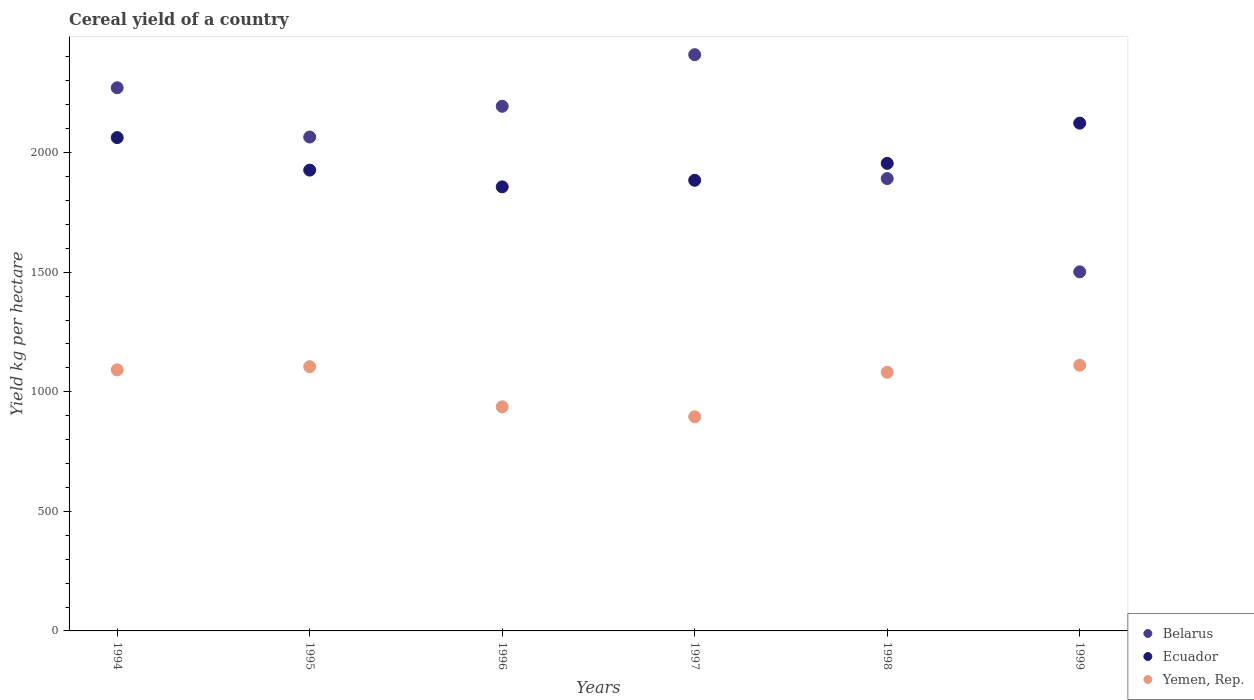What is the total cereal yield in Yemen, Rep. in 1995?
Offer a very short reply. 1104.99. Across all years, what is the maximum total cereal yield in Belarus?
Make the answer very short. 2409.44. Across all years, what is the minimum total cereal yield in Yemen, Rep.?
Offer a terse response. 895.44. In which year was the total cereal yield in Belarus maximum?
Your response must be concise. 1997. In which year was the total cereal yield in Belarus minimum?
Provide a short and direct response. 1999. What is the total total cereal yield in Yemen, Rep. in the graph?
Provide a succinct answer. 6221.8. What is the difference between the total cereal yield in Belarus in 1995 and that in 1998?
Make the answer very short. 173.69. What is the difference between the total cereal yield in Yemen, Rep. in 1994 and the total cereal yield in Ecuador in 1995?
Make the answer very short. -835.14. What is the average total cereal yield in Yemen, Rep. per year?
Provide a succinct answer. 1036.97. In the year 1997, what is the difference between the total cereal yield in Ecuador and total cereal yield in Belarus?
Offer a very short reply. -525.23. What is the ratio of the total cereal yield in Ecuador in 1995 to that in 1996?
Your response must be concise. 1.04. Is the difference between the total cereal yield in Ecuador in 1998 and 1999 greater than the difference between the total cereal yield in Belarus in 1998 and 1999?
Provide a short and direct response. No. What is the difference between the highest and the second highest total cereal yield in Belarus?
Your answer should be compact. 138.28. What is the difference between the highest and the lowest total cereal yield in Belarus?
Ensure brevity in your answer.  907.98. Is the sum of the total cereal yield in Belarus in 1994 and 1998 greater than the maximum total cereal yield in Yemen, Rep. across all years?
Offer a terse response. Yes. Is it the case that in every year, the sum of the total cereal yield in Ecuador and total cereal yield in Yemen, Rep.  is greater than the total cereal yield in Belarus?
Make the answer very short. Yes. Is the total cereal yield in Belarus strictly less than the total cereal yield in Ecuador over the years?
Your answer should be very brief. No. Are the values on the major ticks of Y-axis written in scientific E-notation?
Provide a short and direct response. No. Does the graph contain grids?
Give a very brief answer. No. Where does the legend appear in the graph?
Make the answer very short. Bottom right. How many legend labels are there?
Your answer should be very brief. 3. What is the title of the graph?
Your response must be concise. Cereal yield of a country. What is the label or title of the X-axis?
Your answer should be very brief. Years. What is the label or title of the Y-axis?
Your answer should be compact. Yield kg per hectare. What is the Yield kg per hectare of Belarus in 1994?
Your response must be concise. 2271.15. What is the Yield kg per hectare of Ecuador in 1994?
Your answer should be very brief. 2062.74. What is the Yield kg per hectare in Yemen, Rep. in 1994?
Your response must be concise. 1091.65. What is the Yield kg per hectare in Belarus in 1995?
Provide a short and direct response. 2065.16. What is the Yield kg per hectare of Ecuador in 1995?
Keep it short and to the point. 1926.79. What is the Yield kg per hectare of Yemen, Rep. in 1995?
Keep it short and to the point. 1104.99. What is the Yield kg per hectare of Belarus in 1996?
Ensure brevity in your answer.  2193.68. What is the Yield kg per hectare of Ecuador in 1996?
Offer a very short reply. 1856.78. What is the Yield kg per hectare in Yemen, Rep. in 1996?
Keep it short and to the point. 937.09. What is the Yield kg per hectare of Belarus in 1997?
Provide a short and direct response. 2409.44. What is the Yield kg per hectare of Ecuador in 1997?
Give a very brief answer. 1884.2. What is the Yield kg per hectare of Yemen, Rep. in 1997?
Provide a succinct answer. 895.44. What is the Yield kg per hectare in Belarus in 1998?
Make the answer very short. 1891.47. What is the Yield kg per hectare in Ecuador in 1998?
Make the answer very short. 1955.01. What is the Yield kg per hectare in Yemen, Rep. in 1998?
Keep it short and to the point. 1081.46. What is the Yield kg per hectare of Belarus in 1999?
Your response must be concise. 1501.45. What is the Yield kg per hectare of Ecuador in 1999?
Give a very brief answer. 2123.2. What is the Yield kg per hectare in Yemen, Rep. in 1999?
Give a very brief answer. 1111.16. Across all years, what is the maximum Yield kg per hectare of Belarus?
Ensure brevity in your answer.  2409.44. Across all years, what is the maximum Yield kg per hectare in Ecuador?
Your response must be concise. 2123.2. Across all years, what is the maximum Yield kg per hectare in Yemen, Rep.?
Your answer should be very brief. 1111.16. Across all years, what is the minimum Yield kg per hectare in Belarus?
Provide a short and direct response. 1501.45. Across all years, what is the minimum Yield kg per hectare in Ecuador?
Keep it short and to the point. 1856.78. Across all years, what is the minimum Yield kg per hectare of Yemen, Rep.?
Make the answer very short. 895.44. What is the total Yield kg per hectare in Belarus in the graph?
Provide a succinct answer. 1.23e+04. What is the total Yield kg per hectare in Ecuador in the graph?
Provide a short and direct response. 1.18e+04. What is the total Yield kg per hectare in Yemen, Rep. in the graph?
Your response must be concise. 6221.8. What is the difference between the Yield kg per hectare in Belarus in 1994 and that in 1995?
Make the answer very short. 205.99. What is the difference between the Yield kg per hectare in Ecuador in 1994 and that in 1995?
Provide a succinct answer. 135.95. What is the difference between the Yield kg per hectare of Yemen, Rep. in 1994 and that in 1995?
Your answer should be very brief. -13.35. What is the difference between the Yield kg per hectare of Belarus in 1994 and that in 1996?
Ensure brevity in your answer.  77.47. What is the difference between the Yield kg per hectare in Ecuador in 1994 and that in 1996?
Offer a terse response. 205.97. What is the difference between the Yield kg per hectare in Yemen, Rep. in 1994 and that in 1996?
Keep it short and to the point. 154.56. What is the difference between the Yield kg per hectare of Belarus in 1994 and that in 1997?
Keep it short and to the point. -138.28. What is the difference between the Yield kg per hectare of Ecuador in 1994 and that in 1997?
Your response must be concise. 178.54. What is the difference between the Yield kg per hectare in Yemen, Rep. in 1994 and that in 1997?
Give a very brief answer. 196.21. What is the difference between the Yield kg per hectare in Belarus in 1994 and that in 1998?
Your response must be concise. 379.68. What is the difference between the Yield kg per hectare of Ecuador in 1994 and that in 1998?
Offer a very short reply. 107.73. What is the difference between the Yield kg per hectare of Yemen, Rep. in 1994 and that in 1998?
Provide a succinct answer. 10.19. What is the difference between the Yield kg per hectare of Belarus in 1994 and that in 1999?
Offer a terse response. 769.7. What is the difference between the Yield kg per hectare in Ecuador in 1994 and that in 1999?
Your response must be concise. -60.46. What is the difference between the Yield kg per hectare in Yemen, Rep. in 1994 and that in 1999?
Provide a succinct answer. -19.51. What is the difference between the Yield kg per hectare of Belarus in 1995 and that in 1996?
Keep it short and to the point. -128.51. What is the difference between the Yield kg per hectare in Ecuador in 1995 and that in 1996?
Keep it short and to the point. 70.01. What is the difference between the Yield kg per hectare in Yemen, Rep. in 1995 and that in 1996?
Your answer should be very brief. 167.91. What is the difference between the Yield kg per hectare of Belarus in 1995 and that in 1997?
Offer a very short reply. -344.27. What is the difference between the Yield kg per hectare in Ecuador in 1995 and that in 1997?
Your answer should be compact. 42.59. What is the difference between the Yield kg per hectare of Yemen, Rep. in 1995 and that in 1997?
Provide a succinct answer. 209.55. What is the difference between the Yield kg per hectare in Belarus in 1995 and that in 1998?
Your response must be concise. 173.69. What is the difference between the Yield kg per hectare in Ecuador in 1995 and that in 1998?
Your answer should be compact. -28.22. What is the difference between the Yield kg per hectare in Yemen, Rep. in 1995 and that in 1998?
Keep it short and to the point. 23.53. What is the difference between the Yield kg per hectare of Belarus in 1995 and that in 1999?
Your answer should be compact. 563.71. What is the difference between the Yield kg per hectare in Ecuador in 1995 and that in 1999?
Keep it short and to the point. -196.41. What is the difference between the Yield kg per hectare of Yemen, Rep. in 1995 and that in 1999?
Keep it short and to the point. -6.16. What is the difference between the Yield kg per hectare of Belarus in 1996 and that in 1997?
Make the answer very short. -215.76. What is the difference between the Yield kg per hectare of Ecuador in 1996 and that in 1997?
Give a very brief answer. -27.43. What is the difference between the Yield kg per hectare in Yemen, Rep. in 1996 and that in 1997?
Provide a succinct answer. 41.64. What is the difference between the Yield kg per hectare of Belarus in 1996 and that in 1998?
Provide a short and direct response. 302.2. What is the difference between the Yield kg per hectare of Ecuador in 1996 and that in 1998?
Give a very brief answer. -98.24. What is the difference between the Yield kg per hectare of Yemen, Rep. in 1996 and that in 1998?
Keep it short and to the point. -144.37. What is the difference between the Yield kg per hectare of Belarus in 1996 and that in 1999?
Your answer should be very brief. 692.23. What is the difference between the Yield kg per hectare in Ecuador in 1996 and that in 1999?
Your response must be concise. -266.43. What is the difference between the Yield kg per hectare in Yemen, Rep. in 1996 and that in 1999?
Your answer should be very brief. -174.07. What is the difference between the Yield kg per hectare in Belarus in 1997 and that in 1998?
Provide a short and direct response. 517.96. What is the difference between the Yield kg per hectare of Ecuador in 1997 and that in 1998?
Provide a succinct answer. -70.81. What is the difference between the Yield kg per hectare of Yemen, Rep. in 1997 and that in 1998?
Your answer should be very brief. -186.02. What is the difference between the Yield kg per hectare in Belarus in 1997 and that in 1999?
Keep it short and to the point. 907.99. What is the difference between the Yield kg per hectare of Ecuador in 1997 and that in 1999?
Keep it short and to the point. -239. What is the difference between the Yield kg per hectare of Yemen, Rep. in 1997 and that in 1999?
Give a very brief answer. -215.72. What is the difference between the Yield kg per hectare in Belarus in 1998 and that in 1999?
Your response must be concise. 390.02. What is the difference between the Yield kg per hectare of Ecuador in 1998 and that in 1999?
Offer a very short reply. -168.19. What is the difference between the Yield kg per hectare of Yemen, Rep. in 1998 and that in 1999?
Offer a very short reply. -29.7. What is the difference between the Yield kg per hectare of Belarus in 1994 and the Yield kg per hectare of Ecuador in 1995?
Your response must be concise. 344.36. What is the difference between the Yield kg per hectare of Belarus in 1994 and the Yield kg per hectare of Yemen, Rep. in 1995?
Provide a short and direct response. 1166.16. What is the difference between the Yield kg per hectare in Ecuador in 1994 and the Yield kg per hectare in Yemen, Rep. in 1995?
Your response must be concise. 957.75. What is the difference between the Yield kg per hectare of Belarus in 1994 and the Yield kg per hectare of Ecuador in 1996?
Make the answer very short. 414.38. What is the difference between the Yield kg per hectare in Belarus in 1994 and the Yield kg per hectare in Yemen, Rep. in 1996?
Offer a terse response. 1334.07. What is the difference between the Yield kg per hectare in Ecuador in 1994 and the Yield kg per hectare in Yemen, Rep. in 1996?
Provide a succinct answer. 1125.66. What is the difference between the Yield kg per hectare in Belarus in 1994 and the Yield kg per hectare in Ecuador in 1997?
Keep it short and to the point. 386.95. What is the difference between the Yield kg per hectare of Belarus in 1994 and the Yield kg per hectare of Yemen, Rep. in 1997?
Your answer should be compact. 1375.71. What is the difference between the Yield kg per hectare in Ecuador in 1994 and the Yield kg per hectare in Yemen, Rep. in 1997?
Keep it short and to the point. 1167.3. What is the difference between the Yield kg per hectare of Belarus in 1994 and the Yield kg per hectare of Ecuador in 1998?
Offer a very short reply. 316.14. What is the difference between the Yield kg per hectare in Belarus in 1994 and the Yield kg per hectare in Yemen, Rep. in 1998?
Keep it short and to the point. 1189.69. What is the difference between the Yield kg per hectare in Ecuador in 1994 and the Yield kg per hectare in Yemen, Rep. in 1998?
Your response must be concise. 981.28. What is the difference between the Yield kg per hectare in Belarus in 1994 and the Yield kg per hectare in Ecuador in 1999?
Make the answer very short. 147.95. What is the difference between the Yield kg per hectare of Belarus in 1994 and the Yield kg per hectare of Yemen, Rep. in 1999?
Provide a short and direct response. 1159.99. What is the difference between the Yield kg per hectare in Ecuador in 1994 and the Yield kg per hectare in Yemen, Rep. in 1999?
Keep it short and to the point. 951.58. What is the difference between the Yield kg per hectare in Belarus in 1995 and the Yield kg per hectare in Ecuador in 1996?
Make the answer very short. 208.39. What is the difference between the Yield kg per hectare in Belarus in 1995 and the Yield kg per hectare in Yemen, Rep. in 1996?
Your response must be concise. 1128.08. What is the difference between the Yield kg per hectare in Ecuador in 1995 and the Yield kg per hectare in Yemen, Rep. in 1996?
Ensure brevity in your answer.  989.7. What is the difference between the Yield kg per hectare in Belarus in 1995 and the Yield kg per hectare in Ecuador in 1997?
Make the answer very short. 180.96. What is the difference between the Yield kg per hectare in Belarus in 1995 and the Yield kg per hectare in Yemen, Rep. in 1997?
Offer a terse response. 1169.72. What is the difference between the Yield kg per hectare of Ecuador in 1995 and the Yield kg per hectare of Yemen, Rep. in 1997?
Make the answer very short. 1031.35. What is the difference between the Yield kg per hectare of Belarus in 1995 and the Yield kg per hectare of Ecuador in 1998?
Make the answer very short. 110.15. What is the difference between the Yield kg per hectare of Belarus in 1995 and the Yield kg per hectare of Yemen, Rep. in 1998?
Make the answer very short. 983.7. What is the difference between the Yield kg per hectare of Ecuador in 1995 and the Yield kg per hectare of Yemen, Rep. in 1998?
Keep it short and to the point. 845.33. What is the difference between the Yield kg per hectare in Belarus in 1995 and the Yield kg per hectare in Ecuador in 1999?
Give a very brief answer. -58.04. What is the difference between the Yield kg per hectare in Belarus in 1995 and the Yield kg per hectare in Yemen, Rep. in 1999?
Keep it short and to the point. 954. What is the difference between the Yield kg per hectare in Ecuador in 1995 and the Yield kg per hectare in Yemen, Rep. in 1999?
Provide a succinct answer. 815.63. What is the difference between the Yield kg per hectare in Belarus in 1996 and the Yield kg per hectare in Ecuador in 1997?
Your response must be concise. 309.48. What is the difference between the Yield kg per hectare in Belarus in 1996 and the Yield kg per hectare in Yemen, Rep. in 1997?
Ensure brevity in your answer.  1298.23. What is the difference between the Yield kg per hectare of Ecuador in 1996 and the Yield kg per hectare of Yemen, Rep. in 1997?
Provide a short and direct response. 961.33. What is the difference between the Yield kg per hectare of Belarus in 1996 and the Yield kg per hectare of Ecuador in 1998?
Your answer should be very brief. 238.66. What is the difference between the Yield kg per hectare in Belarus in 1996 and the Yield kg per hectare in Yemen, Rep. in 1998?
Offer a terse response. 1112.22. What is the difference between the Yield kg per hectare in Ecuador in 1996 and the Yield kg per hectare in Yemen, Rep. in 1998?
Provide a succinct answer. 775.31. What is the difference between the Yield kg per hectare in Belarus in 1996 and the Yield kg per hectare in Ecuador in 1999?
Make the answer very short. 70.48. What is the difference between the Yield kg per hectare in Belarus in 1996 and the Yield kg per hectare in Yemen, Rep. in 1999?
Your response must be concise. 1082.52. What is the difference between the Yield kg per hectare of Ecuador in 1996 and the Yield kg per hectare of Yemen, Rep. in 1999?
Offer a very short reply. 745.62. What is the difference between the Yield kg per hectare in Belarus in 1997 and the Yield kg per hectare in Ecuador in 1998?
Provide a succinct answer. 454.43. What is the difference between the Yield kg per hectare of Belarus in 1997 and the Yield kg per hectare of Yemen, Rep. in 1998?
Offer a very short reply. 1327.98. What is the difference between the Yield kg per hectare of Ecuador in 1997 and the Yield kg per hectare of Yemen, Rep. in 1998?
Ensure brevity in your answer.  802.74. What is the difference between the Yield kg per hectare in Belarus in 1997 and the Yield kg per hectare in Ecuador in 1999?
Ensure brevity in your answer.  286.24. What is the difference between the Yield kg per hectare of Belarus in 1997 and the Yield kg per hectare of Yemen, Rep. in 1999?
Ensure brevity in your answer.  1298.28. What is the difference between the Yield kg per hectare of Ecuador in 1997 and the Yield kg per hectare of Yemen, Rep. in 1999?
Offer a terse response. 773.04. What is the difference between the Yield kg per hectare of Belarus in 1998 and the Yield kg per hectare of Ecuador in 1999?
Your response must be concise. -231.73. What is the difference between the Yield kg per hectare in Belarus in 1998 and the Yield kg per hectare in Yemen, Rep. in 1999?
Offer a very short reply. 780.32. What is the difference between the Yield kg per hectare in Ecuador in 1998 and the Yield kg per hectare in Yemen, Rep. in 1999?
Offer a very short reply. 843.85. What is the average Yield kg per hectare in Belarus per year?
Offer a terse response. 2055.39. What is the average Yield kg per hectare of Ecuador per year?
Your response must be concise. 1968.12. What is the average Yield kg per hectare in Yemen, Rep. per year?
Your answer should be compact. 1036.97. In the year 1994, what is the difference between the Yield kg per hectare in Belarus and Yield kg per hectare in Ecuador?
Your answer should be compact. 208.41. In the year 1994, what is the difference between the Yield kg per hectare of Belarus and Yield kg per hectare of Yemen, Rep.?
Your answer should be very brief. 1179.5. In the year 1994, what is the difference between the Yield kg per hectare of Ecuador and Yield kg per hectare of Yemen, Rep.?
Make the answer very short. 971.09. In the year 1995, what is the difference between the Yield kg per hectare in Belarus and Yield kg per hectare in Ecuador?
Ensure brevity in your answer.  138.37. In the year 1995, what is the difference between the Yield kg per hectare of Belarus and Yield kg per hectare of Yemen, Rep.?
Provide a succinct answer. 960.17. In the year 1995, what is the difference between the Yield kg per hectare in Ecuador and Yield kg per hectare in Yemen, Rep.?
Give a very brief answer. 821.79. In the year 1996, what is the difference between the Yield kg per hectare in Belarus and Yield kg per hectare in Ecuador?
Provide a succinct answer. 336.9. In the year 1996, what is the difference between the Yield kg per hectare of Belarus and Yield kg per hectare of Yemen, Rep.?
Ensure brevity in your answer.  1256.59. In the year 1996, what is the difference between the Yield kg per hectare in Ecuador and Yield kg per hectare in Yemen, Rep.?
Ensure brevity in your answer.  919.69. In the year 1997, what is the difference between the Yield kg per hectare in Belarus and Yield kg per hectare in Ecuador?
Offer a very short reply. 525.24. In the year 1997, what is the difference between the Yield kg per hectare in Belarus and Yield kg per hectare in Yemen, Rep.?
Ensure brevity in your answer.  1513.99. In the year 1997, what is the difference between the Yield kg per hectare in Ecuador and Yield kg per hectare in Yemen, Rep.?
Your answer should be compact. 988.76. In the year 1998, what is the difference between the Yield kg per hectare of Belarus and Yield kg per hectare of Ecuador?
Your response must be concise. -63.54. In the year 1998, what is the difference between the Yield kg per hectare of Belarus and Yield kg per hectare of Yemen, Rep.?
Make the answer very short. 810.01. In the year 1998, what is the difference between the Yield kg per hectare in Ecuador and Yield kg per hectare in Yemen, Rep.?
Keep it short and to the point. 873.55. In the year 1999, what is the difference between the Yield kg per hectare of Belarus and Yield kg per hectare of Ecuador?
Your response must be concise. -621.75. In the year 1999, what is the difference between the Yield kg per hectare in Belarus and Yield kg per hectare in Yemen, Rep.?
Offer a terse response. 390.29. In the year 1999, what is the difference between the Yield kg per hectare in Ecuador and Yield kg per hectare in Yemen, Rep.?
Keep it short and to the point. 1012.04. What is the ratio of the Yield kg per hectare in Belarus in 1994 to that in 1995?
Offer a terse response. 1.1. What is the ratio of the Yield kg per hectare in Ecuador in 1994 to that in 1995?
Give a very brief answer. 1.07. What is the ratio of the Yield kg per hectare in Yemen, Rep. in 1994 to that in 1995?
Give a very brief answer. 0.99. What is the ratio of the Yield kg per hectare in Belarus in 1994 to that in 1996?
Your answer should be compact. 1.04. What is the ratio of the Yield kg per hectare of Ecuador in 1994 to that in 1996?
Keep it short and to the point. 1.11. What is the ratio of the Yield kg per hectare of Yemen, Rep. in 1994 to that in 1996?
Provide a succinct answer. 1.16. What is the ratio of the Yield kg per hectare in Belarus in 1994 to that in 1997?
Provide a succinct answer. 0.94. What is the ratio of the Yield kg per hectare of Ecuador in 1994 to that in 1997?
Keep it short and to the point. 1.09. What is the ratio of the Yield kg per hectare of Yemen, Rep. in 1994 to that in 1997?
Your answer should be compact. 1.22. What is the ratio of the Yield kg per hectare in Belarus in 1994 to that in 1998?
Provide a succinct answer. 1.2. What is the ratio of the Yield kg per hectare of Ecuador in 1994 to that in 1998?
Make the answer very short. 1.06. What is the ratio of the Yield kg per hectare of Yemen, Rep. in 1994 to that in 1998?
Your response must be concise. 1.01. What is the ratio of the Yield kg per hectare in Belarus in 1994 to that in 1999?
Your answer should be compact. 1.51. What is the ratio of the Yield kg per hectare of Ecuador in 1994 to that in 1999?
Ensure brevity in your answer.  0.97. What is the ratio of the Yield kg per hectare of Yemen, Rep. in 1994 to that in 1999?
Offer a very short reply. 0.98. What is the ratio of the Yield kg per hectare in Belarus in 1995 to that in 1996?
Ensure brevity in your answer.  0.94. What is the ratio of the Yield kg per hectare in Ecuador in 1995 to that in 1996?
Offer a terse response. 1.04. What is the ratio of the Yield kg per hectare in Yemen, Rep. in 1995 to that in 1996?
Your answer should be compact. 1.18. What is the ratio of the Yield kg per hectare of Ecuador in 1995 to that in 1997?
Your answer should be very brief. 1.02. What is the ratio of the Yield kg per hectare in Yemen, Rep. in 1995 to that in 1997?
Ensure brevity in your answer.  1.23. What is the ratio of the Yield kg per hectare in Belarus in 1995 to that in 1998?
Make the answer very short. 1.09. What is the ratio of the Yield kg per hectare in Ecuador in 1995 to that in 1998?
Make the answer very short. 0.99. What is the ratio of the Yield kg per hectare of Yemen, Rep. in 1995 to that in 1998?
Offer a very short reply. 1.02. What is the ratio of the Yield kg per hectare in Belarus in 1995 to that in 1999?
Your response must be concise. 1.38. What is the ratio of the Yield kg per hectare in Ecuador in 1995 to that in 1999?
Provide a short and direct response. 0.91. What is the ratio of the Yield kg per hectare of Belarus in 1996 to that in 1997?
Your response must be concise. 0.91. What is the ratio of the Yield kg per hectare of Ecuador in 1996 to that in 1997?
Offer a terse response. 0.99. What is the ratio of the Yield kg per hectare in Yemen, Rep. in 1996 to that in 1997?
Keep it short and to the point. 1.05. What is the ratio of the Yield kg per hectare of Belarus in 1996 to that in 1998?
Your response must be concise. 1.16. What is the ratio of the Yield kg per hectare in Ecuador in 1996 to that in 1998?
Your response must be concise. 0.95. What is the ratio of the Yield kg per hectare of Yemen, Rep. in 1996 to that in 1998?
Provide a short and direct response. 0.87. What is the ratio of the Yield kg per hectare in Belarus in 1996 to that in 1999?
Keep it short and to the point. 1.46. What is the ratio of the Yield kg per hectare of Ecuador in 1996 to that in 1999?
Provide a succinct answer. 0.87. What is the ratio of the Yield kg per hectare in Yemen, Rep. in 1996 to that in 1999?
Provide a short and direct response. 0.84. What is the ratio of the Yield kg per hectare in Belarus in 1997 to that in 1998?
Provide a succinct answer. 1.27. What is the ratio of the Yield kg per hectare of Ecuador in 1997 to that in 1998?
Keep it short and to the point. 0.96. What is the ratio of the Yield kg per hectare in Yemen, Rep. in 1997 to that in 1998?
Offer a terse response. 0.83. What is the ratio of the Yield kg per hectare of Belarus in 1997 to that in 1999?
Keep it short and to the point. 1.6. What is the ratio of the Yield kg per hectare of Ecuador in 1997 to that in 1999?
Give a very brief answer. 0.89. What is the ratio of the Yield kg per hectare of Yemen, Rep. in 1997 to that in 1999?
Ensure brevity in your answer.  0.81. What is the ratio of the Yield kg per hectare of Belarus in 1998 to that in 1999?
Give a very brief answer. 1.26. What is the ratio of the Yield kg per hectare of Ecuador in 1998 to that in 1999?
Provide a short and direct response. 0.92. What is the ratio of the Yield kg per hectare in Yemen, Rep. in 1998 to that in 1999?
Offer a terse response. 0.97. What is the difference between the highest and the second highest Yield kg per hectare in Belarus?
Provide a succinct answer. 138.28. What is the difference between the highest and the second highest Yield kg per hectare of Ecuador?
Give a very brief answer. 60.46. What is the difference between the highest and the second highest Yield kg per hectare of Yemen, Rep.?
Your answer should be very brief. 6.16. What is the difference between the highest and the lowest Yield kg per hectare of Belarus?
Your response must be concise. 907.99. What is the difference between the highest and the lowest Yield kg per hectare of Ecuador?
Offer a very short reply. 266.43. What is the difference between the highest and the lowest Yield kg per hectare of Yemen, Rep.?
Offer a terse response. 215.72. 